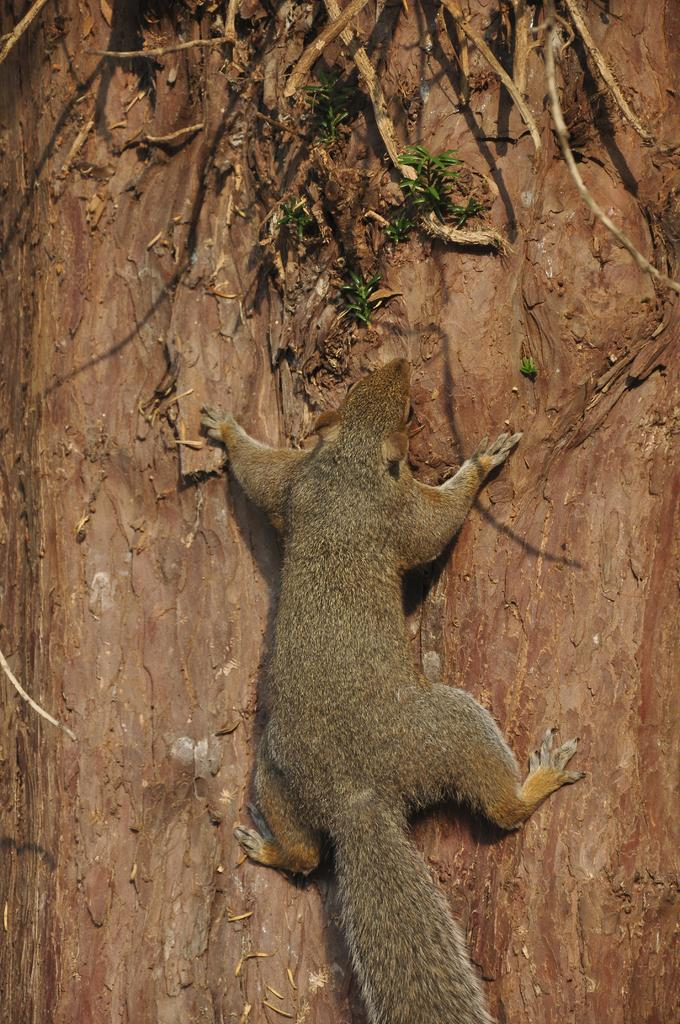What animal is present in the image? There is a squirrel in the image. What is the squirrel doing in the image? The squirrel is climbing a tree. What type of sofa is the squirrel sitting on in the image? There is no sofa present in the image; the squirrel is climbing a tree. 